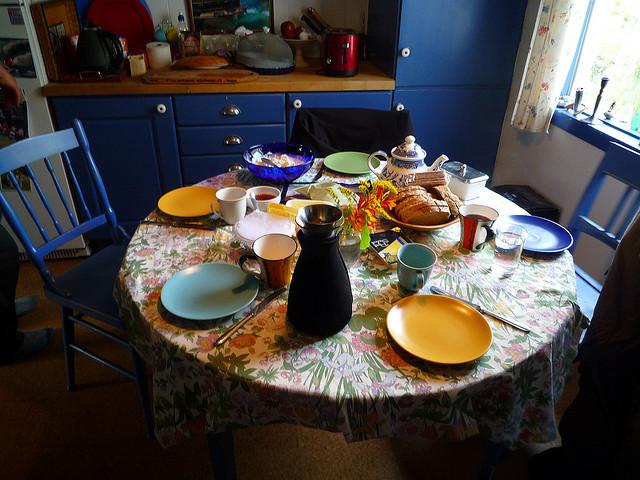Did someone set the table for guests?
Keep it brief. Yes. How many people can sit in chairs?
Be succinct. 3. How many place settings are at the table?
Concise answer only. 5. 